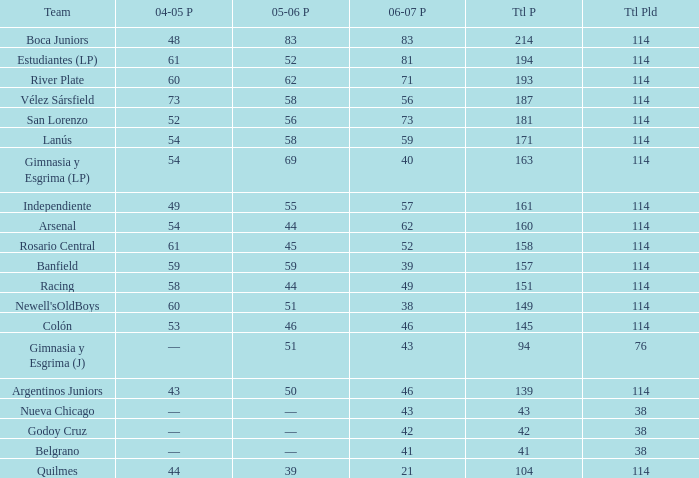What is the total pld with 158 points in 2006-07, and less than 52 points in 2006-07? None. 